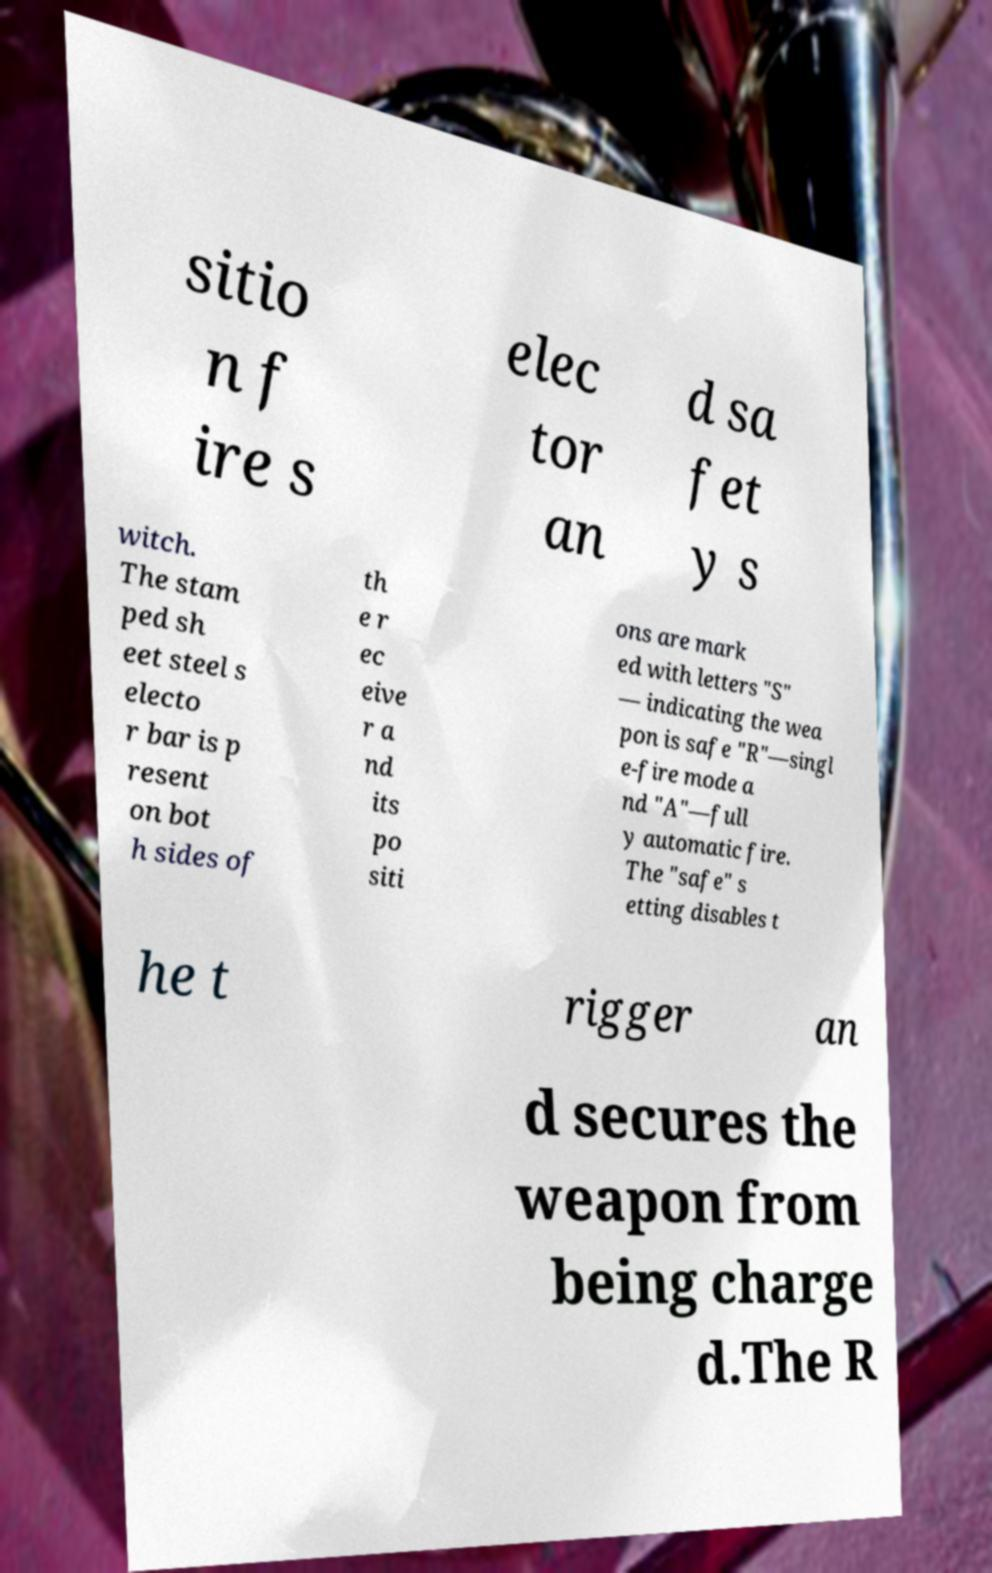Please identify and transcribe the text found in this image. sitio n f ire s elec tor an d sa fet y s witch. The stam ped sh eet steel s electo r bar is p resent on bot h sides of th e r ec eive r a nd its po siti ons are mark ed with letters "S" — indicating the wea pon is safe "R"—singl e-fire mode a nd "A"—full y automatic fire. The "safe" s etting disables t he t rigger an d secures the weapon from being charge d.The R 